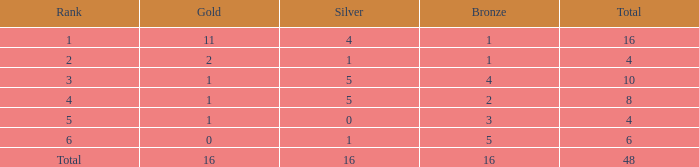How many total gold are less than 4? 0.0. 